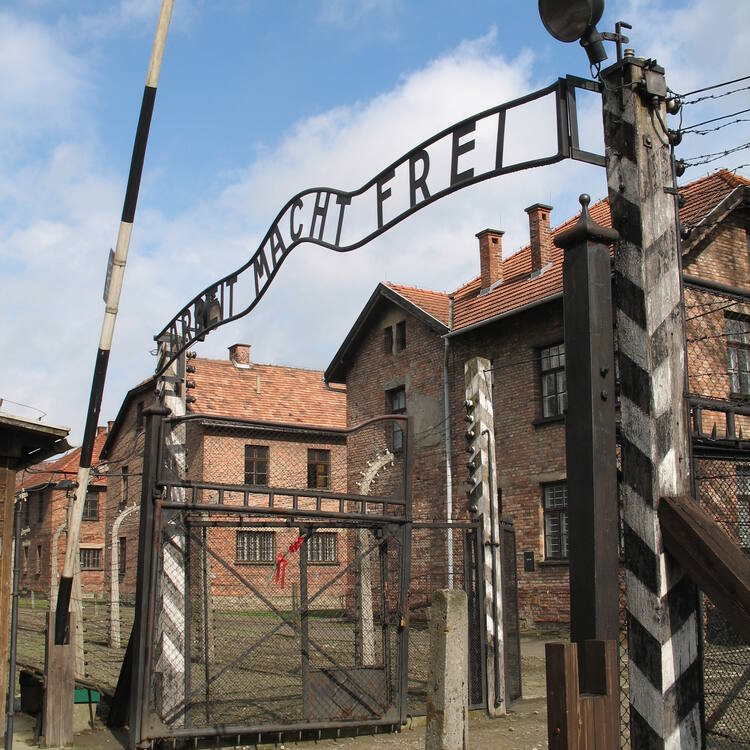Imagine the scene through the eyes of a bird flying above the camp. Describe what it sees. From the perspective of a bird soaring above Auschwitz, the scene below is a chilling panorama of stark and haunting contrasts. The bird sees the orderly rows of somber brick buildings enclosed by an intricate web of barbed wire. The infamous gate with its grim slogan is just one of many entrances to this vast complex. The nearby watchtowers and barracks lay sprawled beneath its wings, their rigid structures belying the chaotic and cruel reality within. A path leading into the depths of the camp stretches out like a scar against the earth. Despite the clear, blue sky above, the atmosphere below is tense and oppressive, a stark reminder of the camp's history. The bird sees not only the physical remnants of this past but also senses the lingering sorrow and echoes of countless lost lives that seem to rise from the ground and touch the sky. 